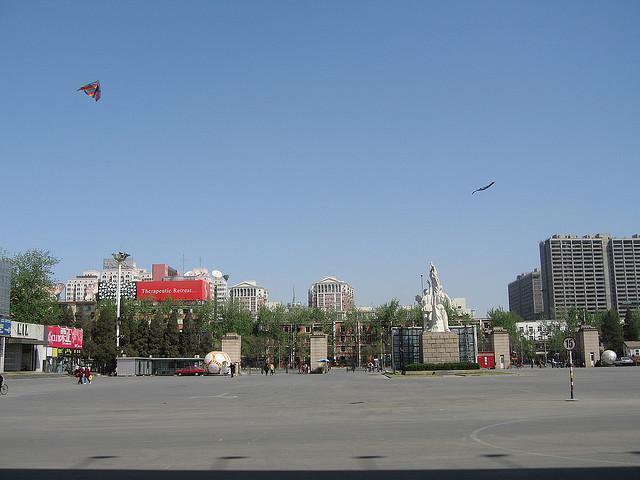How many shadows are in the picture?
Give a very brief answer. 5. How many red cars are on the street?
Give a very brief answer. 1. How many chair legs are touching only the orange surface of the floor?
Give a very brief answer. 0. 